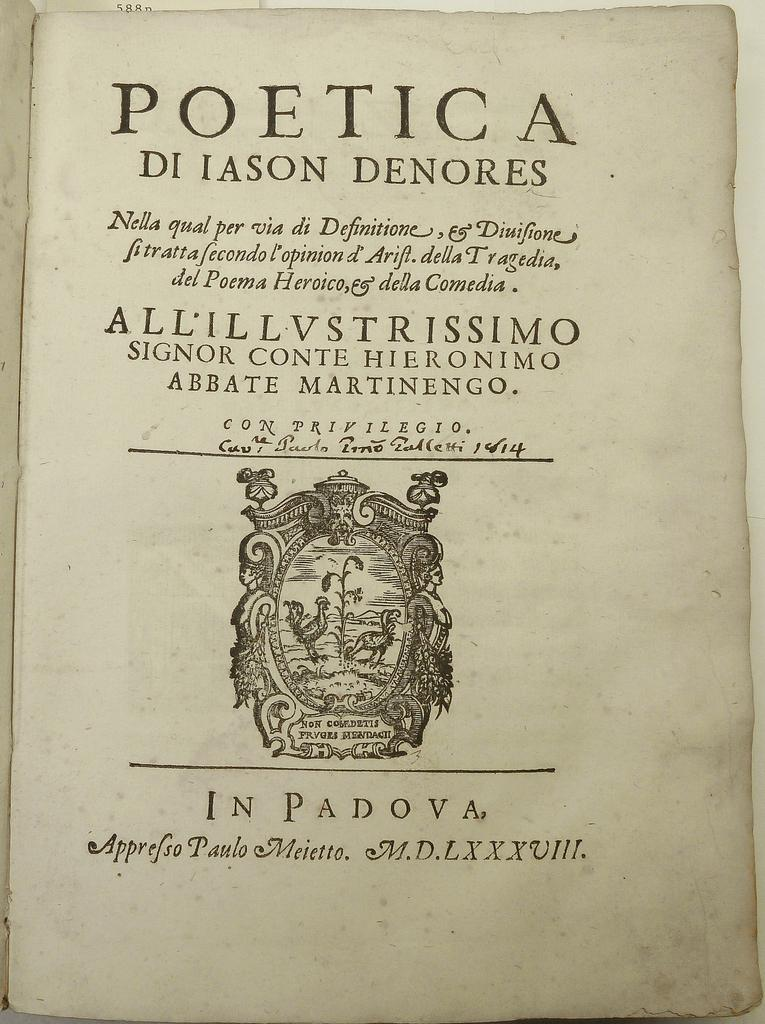What is present on the paper in the image? The paper has text and an image on it. Can you describe the text on the paper? Unfortunately, the specific content of the text cannot be determined from the image. What type of image is on the paper? The image on the paper cannot be identified from the image itself. What color is the cap on the orange in the image? There is no cap or orange present in the image; it only features a paper with text and an image. 